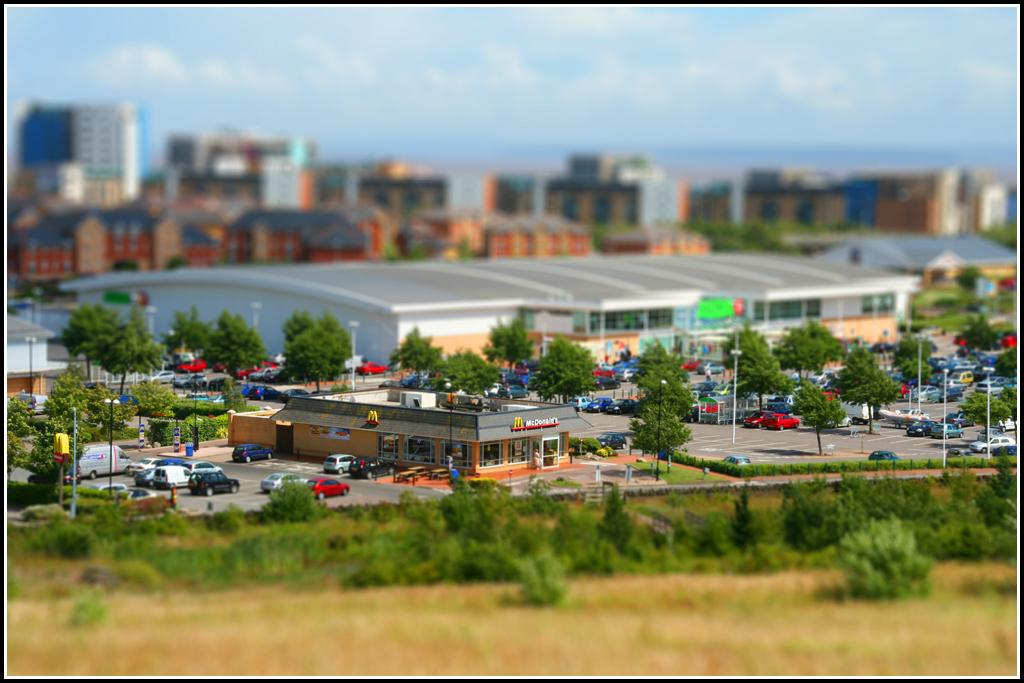What type of vegetation can be seen in the image? There are green color plants and trees in the image. What type of man-made structures are present in the image? There are buildings in the image. What type of vehicles can be seen in the image? There are cars in the image. What is visible at the top of the image? The sky is visible at the top of the image. Can you tell me how many jewels are on the trees in the image? There are no jewels present on the trees in the image; it features green plants and trees. What type of emotion is the brother displaying in the image? There is no brother present in the image, so it is not possible to determine any emotions related to a brother. 